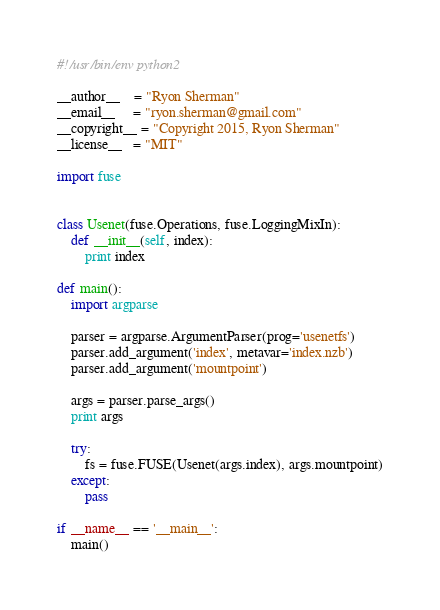<code> <loc_0><loc_0><loc_500><loc_500><_Python_>#!/usr/bin/env python2

__author__    = "Ryon Sherman"
__email__     = "ryon.sherman@gmail.com"
__copyright__ = "Copyright 2015, Ryon Sherman"
__license__   = "MIT"

import fuse


class Usenet(fuse.Operations, fuse.LoggingMixIn):
    def __init__(self, index):
        print index

def main():
    import argparse

    parser = argparse.ArgumentParser(prog='usenetfs')
    parser.add_argument('index', metavar='index.nzb')
    parser.add_argument('mountpoint')

    args = parser.parse_args()
    print args

    try:
        fs = fuse.FUSE(Usenet(args.index), args.mountpoint)
    except:
        pass

if __name__ == '__main__':
    main()</code> 